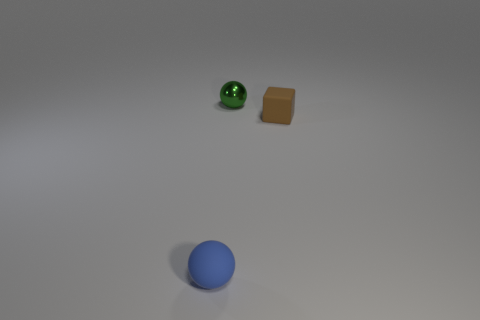Add 1 big red metal cubes. How many objects exist? 4 Subtract all cubes. How many objects are left? 2 Subtract all tiny cyan cylinders. Subtract all brown things. How many objects are left? 2 Add 2 rubber blocks. How many rubber blocks are left? 3 Add 2 green metal things. How many green metal things exist? 3 Subtract 0 gray cubes. How many objects are left? 3 